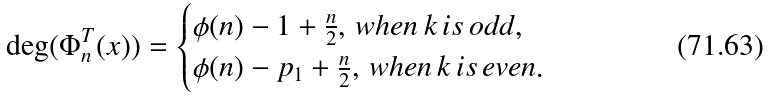Convert formula to latex. <formula><loc_0><loc_0><loc_500><loc_500>\deg ( \Phi ^ { T } _ { n } ( x ) ) = \begin{cases} \phi ( n ) - 1 + \frac { n } { 2 } , \, w h e n \, k \, i s \, o d d , \\ \phi ( n ) - p _ { 1 } + \frac { n } { 2 } , \, w h e n \, k \, i s \, e v e n . \end{cases}</formula> 